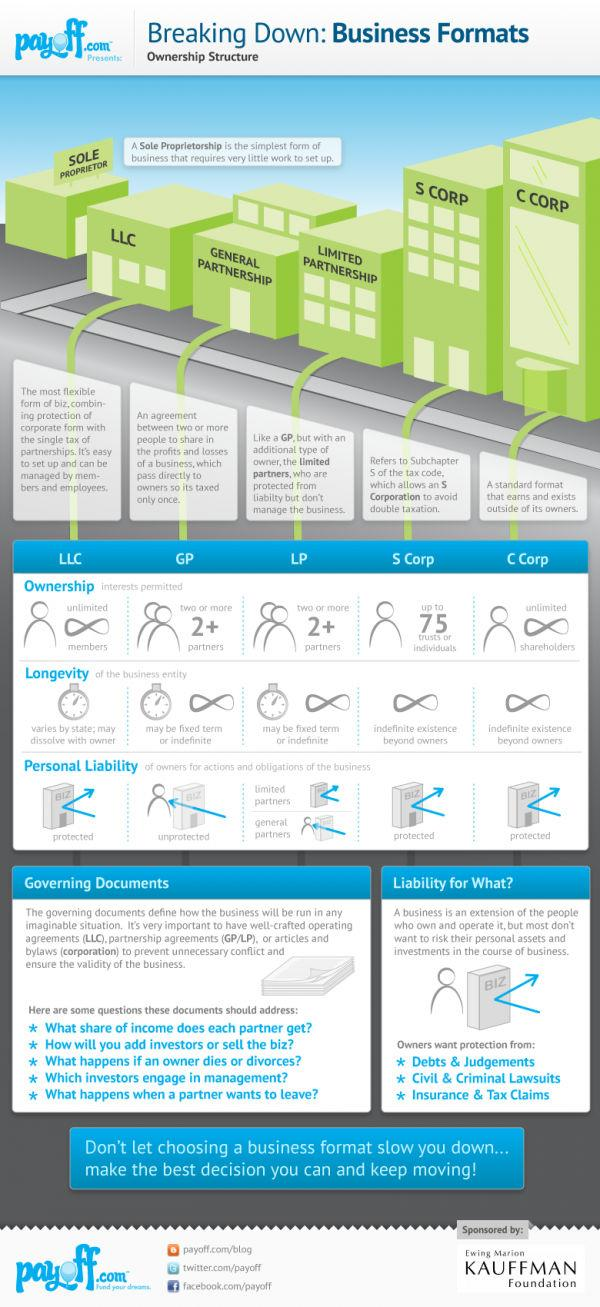Give some essential details in this illustration. The ownership structure that provides protected personal liability of owners is Limited Liability Company (LLC), Subchapter S Corporation (S Corp), and C Corporation. The type of ownership that allows a business to have a maximum lifespan is S Corp or C Corp. Six ownership structures are listed. Limited partnerships and general partnerships are types of ownership that have two or more than two partners. 